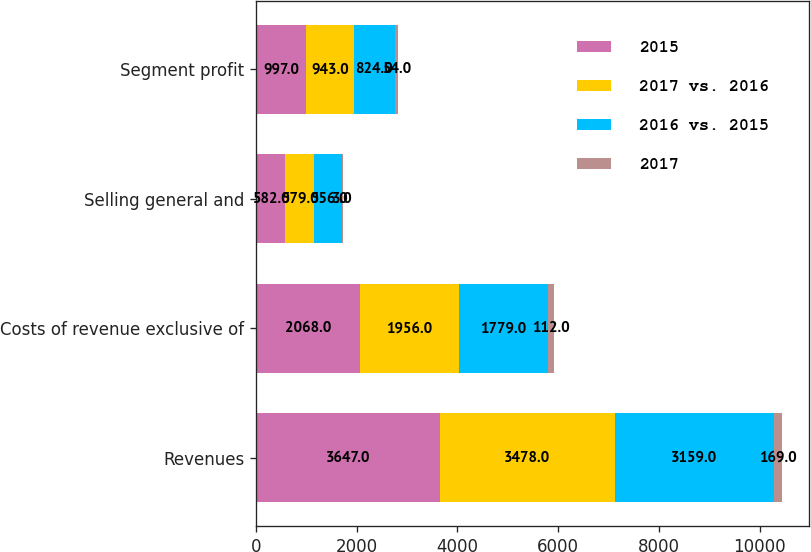Convert chart. <chart><loc_0><loc_0><loc_500><loc_500><stacked_bar_chart><ecel><fcel>Revenues<fcel>Costs of revenue exclusive of<fcel>Selling general and<fcel>Segment profit<nl><fcel>2015<fcel>3647<fcel>2068<fcel>582<fcel>997<nl><fcel>2017 vs. 2016<fcel>3478<fcel>1956<fcel>579<fcel>943<nl><fcel>2016 vs. 2015<fcel>3159<fcel>1779<fcel>556<fcel>824<nl><fcel>2017<fcel>169<fcel>112<fcel>3<fcel>54<nl></chart> 